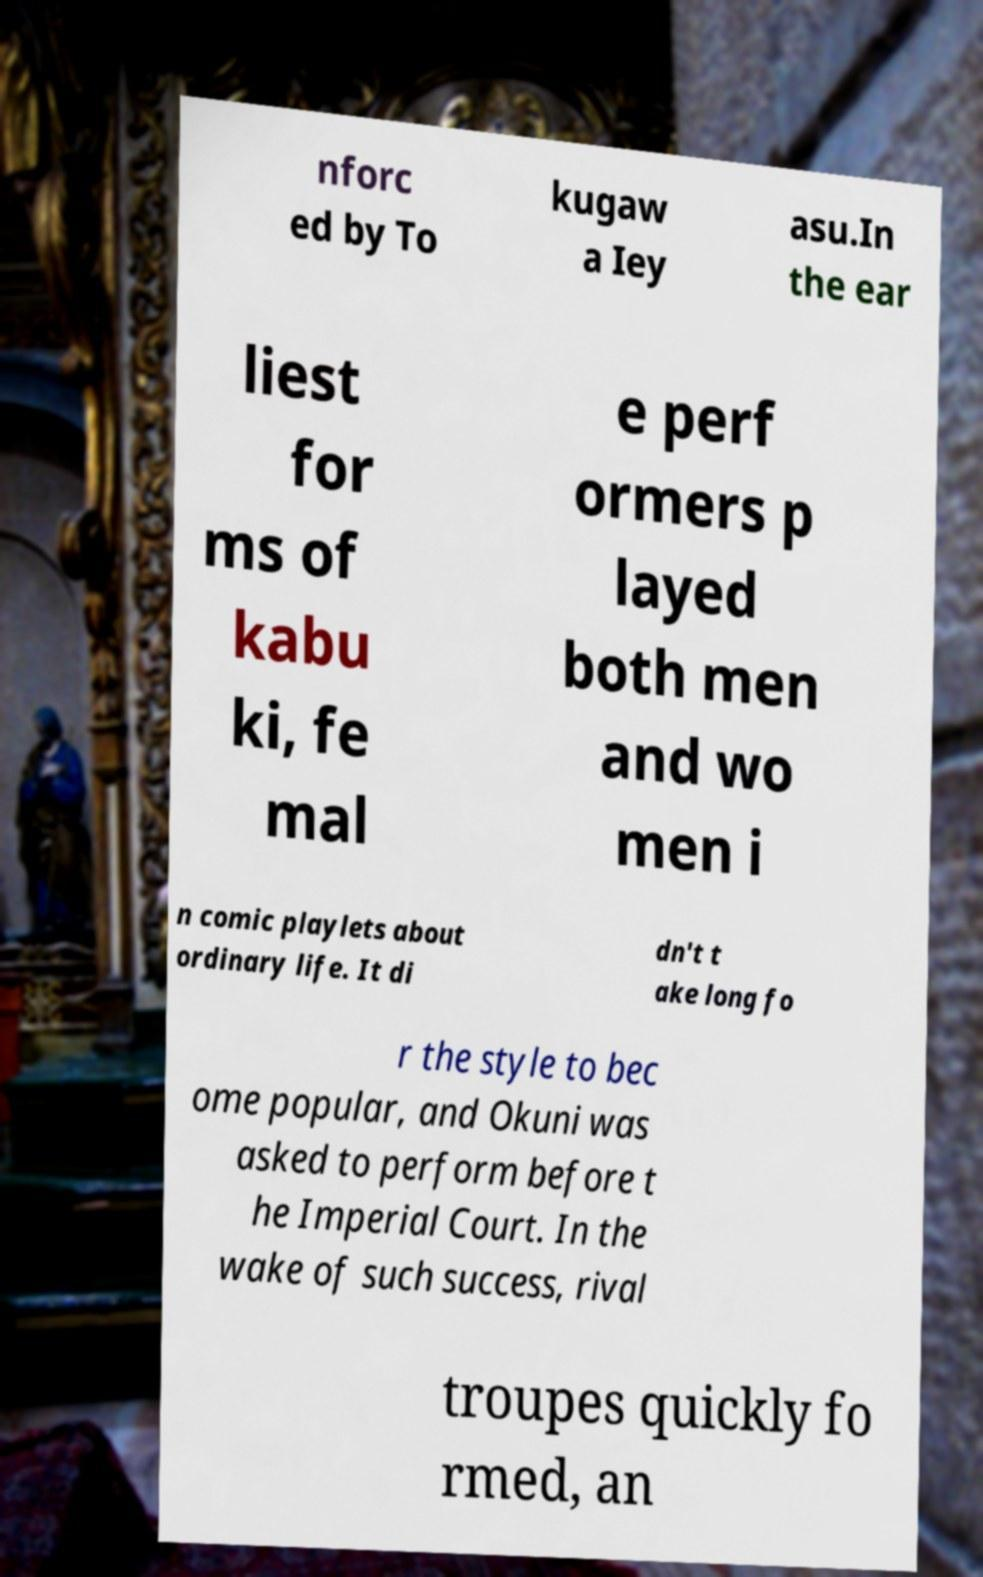Could you extract and type out the text from this image? nforc ed by To kugaw a Iey asu.In the ear liest for ms of kabu ki, fe mal e perf ormers p layed both men and wo men i n comic playlets about ordinary life. It di dn't t ake long fo r the style to bec ome popular, and Okuni was asked to perform before t he Imperial Court. In the wake of such success, rival troupes quickly fo rmed, an 